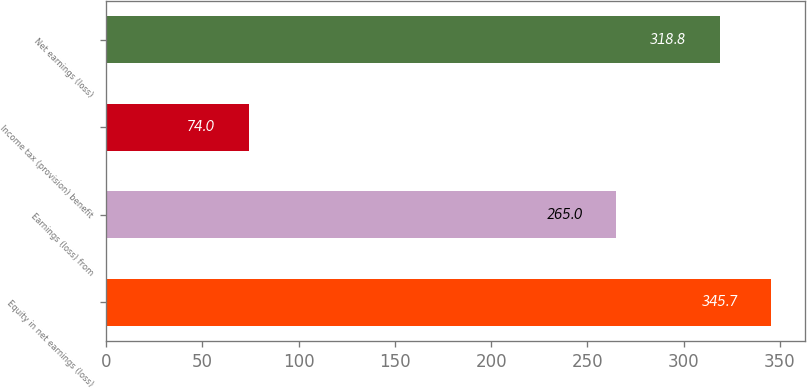Convert chart. <chart><loc_0><loc_0><loc_500><loc_500><bar_chart><fcel>Equity in net earnings (loss)<fcel>Earnings (loss) from<fcel>Income tax (provision) benefit<fcel>Net earnings (loss)<nl><fcel>345.7<fcel>265<fcel>74<fcel>318.8<nl></chart> 